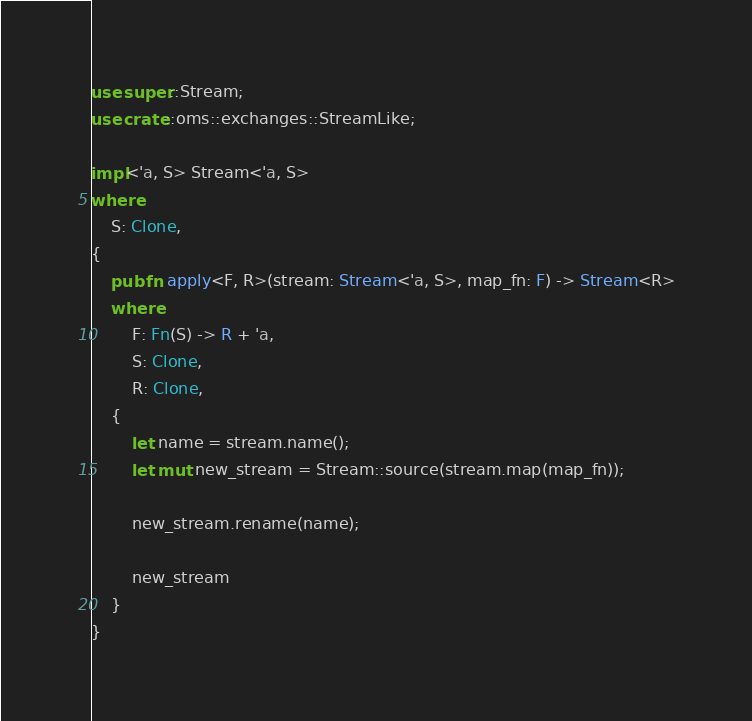Convert code to text. <code><loc_0><loc_0><loc_500><loc_500><_Rust_>use super::Stream;
use crate::oms::exchanges::StreamLike;

impl<'a, S> Stream<'a, S>
where
    S: Clone,
{
    pub fn apply<F, R>(stream: Stream<'a, S>, map_fn: F) -> Stream<R>
    where
        F: Fn(S) -> R + 'a,
        S: Clone,
        R: Clone,
    {
        let name = stream.name();
        let mut new_stream = Stream::source(stream.map(map_fn));

        new_stream.rename(name);

        new_stream
    }
}
</code> 